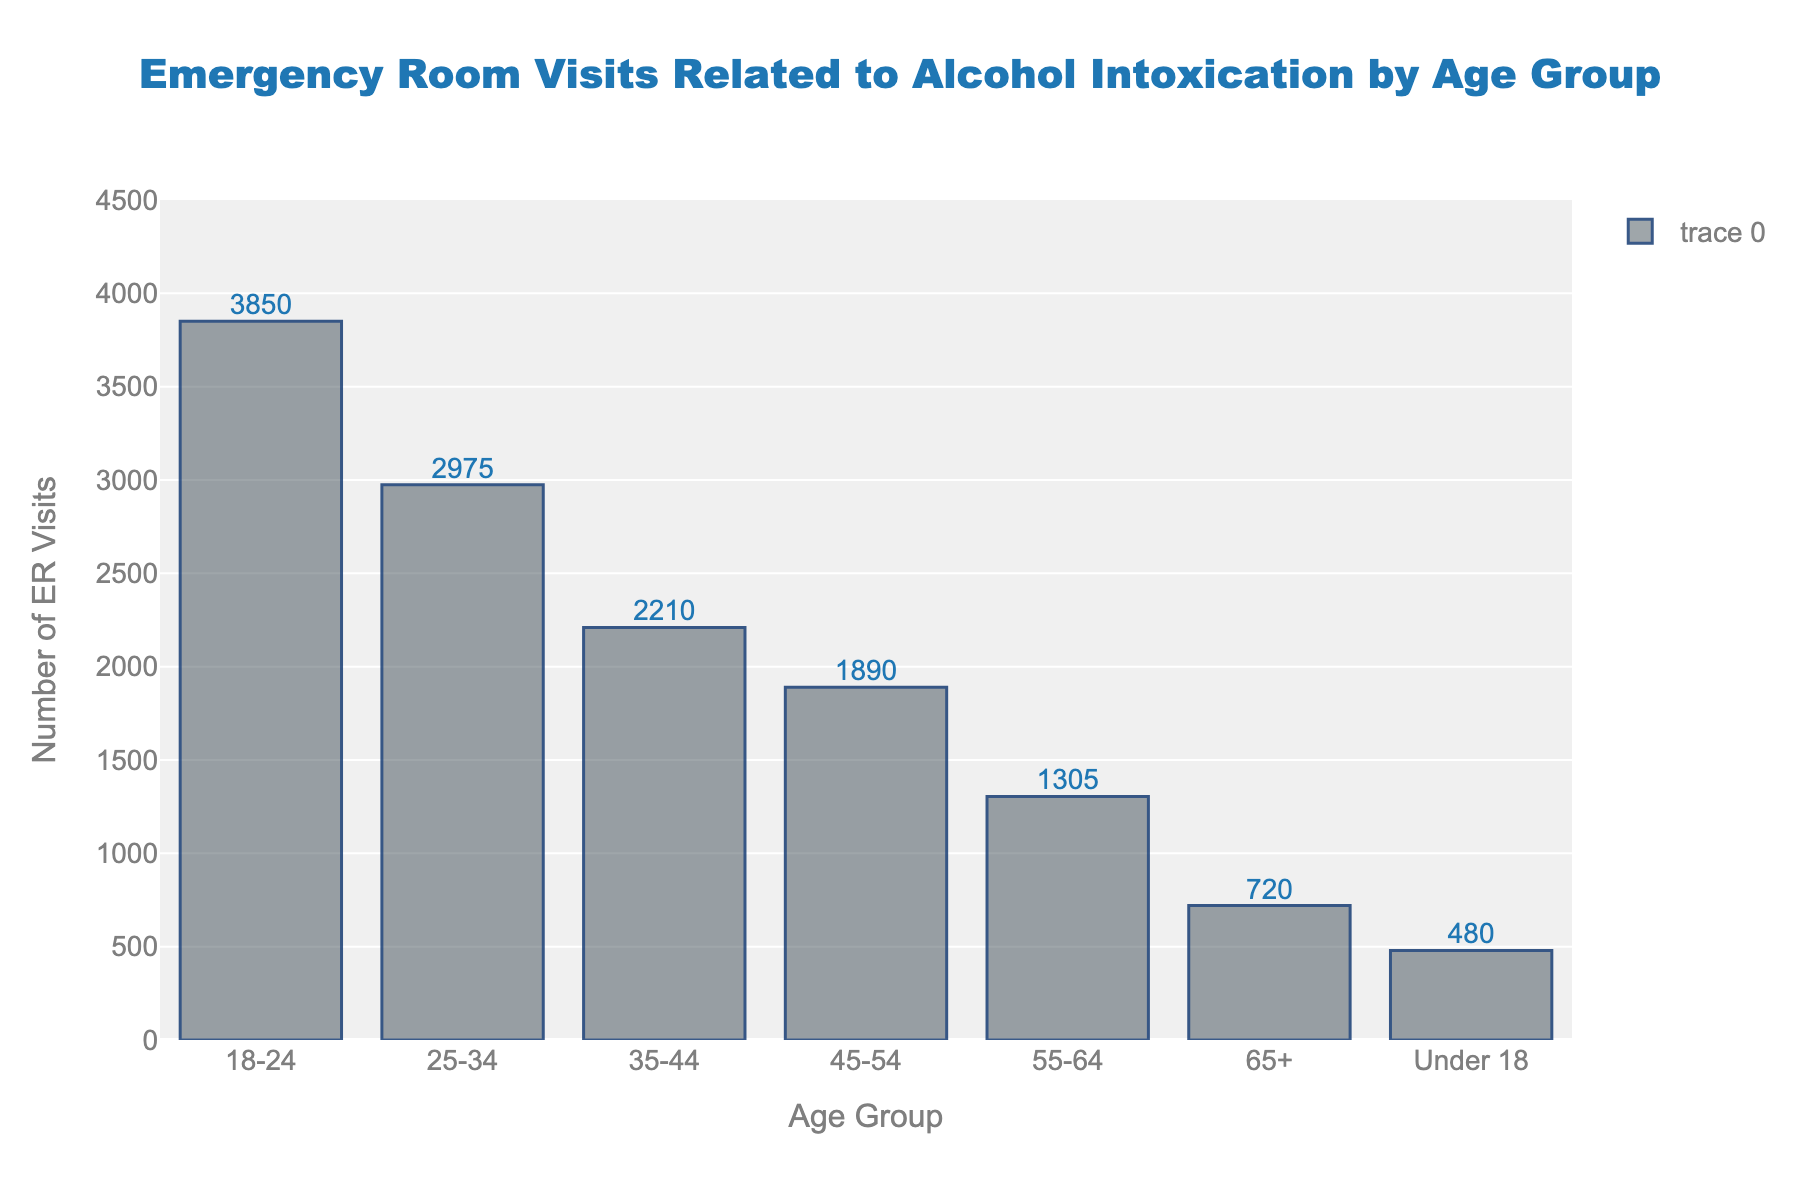Which age group has the highest number of ER visits related to alcohol intoxication? The bar representing the 18-24 age group is the tallest, indicating the highest number of ER visits compared to other age groups.
Answer: 18-24 How many more ER visits are in the 18-24 age group compared to the 45-54 age group? The number of ER visits in the 18-24 age group is 3850, and the number in the 45-54 age group is 1890. The difference is 3850 - 1890 = 1960.
Answer: 1960 What is the cumulative number of ER visits for all age groups over 45? The age groups over 45 are 45-54, 55-64, and 65+. Adding their ER visits: 1890 + 1305 + 720 = 3915.
Answer: 3915 Which age group has the lowest number of ER visits related to alcohol intoxication, and how many visits do they have? The "Under 18" age group has the lowest number of ER visits, with 480 visits.
Answer: Under 18, 480 What is the visual spacing between the bars on the plot? The bars have a consistent spacing between them as shown in the plot with a slight gap indicating separation between different age groups.
Answer: Consistent spacing with gaps Is the number of ER visits for the 25-34 age group more than half of the number for the 18-24 age group? Half of the ER visits for the 18-24 age group is 3850 / 2 = 1925. The 25-34 age group has 2975 ER visits, which is more than 1925.
Answer: Yes What is the difference in the number of ER visits between the age groups 35-44 and 55-64? The number of ER visits for age group 35-44 is 2210, and for 55-64, it is 1305. The difference is 2210 - 1305 = 905.
Answer: 905 How much higher are the ER visits for the 55-64 age group compared to the 65+ age group? The 55-64 age group has 1305 ER visits, and the 65+ age group has 720 ER visits. The difference is 1305 - 720 = 585.
Answer: 585 What is the average number of ER visits for all age groups excluding the "Under 18" group? The total number of ER visits for all age groups excluding "Under 18" is 3850 + 2975 + 2210 + 1890 + 1305 + 720 = 12950. There are six age groups. The average is 12950 / 6 = 2158.33.
Answer: 2158.33 